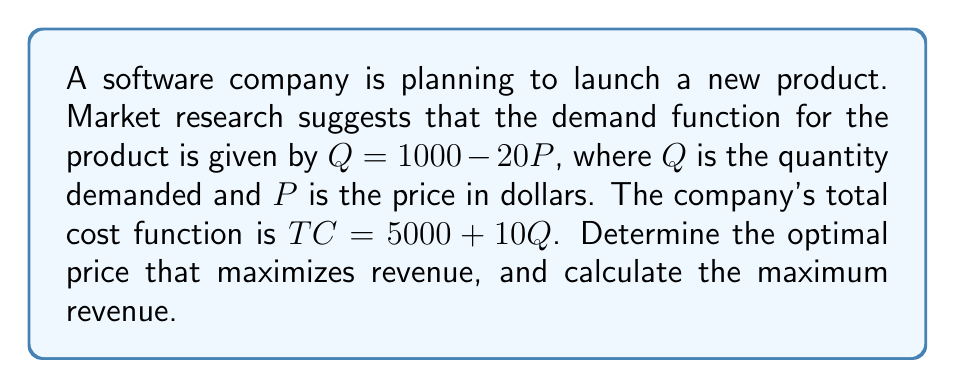Could you help me with this problem? To solve this problem, we'll follow these steps:

1. Define the revenue function
2. Find the first derivative of the revenue function
3. Set the derivative to zero and solve for P
4. Verify that this critical point maximizes revenue
5. Calculate the maximum revenue

Step 1: Define the revenue function
Revenue (R) is price times quantity: $R = P \cdot Q$
Substituting the demand function: $R = P \cdot (1000 - 20P) = 1000P - 20P^2$

Step 2: Find the first derivative of the revenue function
$$\frac{dR}{dP} = 1000 - 40P$$

Step 3: Set the derivative to zero and solve for P
$$1000 - 40P = 0$$
$$40P = 1000$$
$$P = 25$$

Step 4: Verify that this critical point maximizes revenue
To confirm this is a maximum, we can check the second derivative:
$$\frac{d^2R}{dP^2} = -40$$
Since the second derivative is negative, $P = 25$ is indeed a maximum.

Step 5: Calculate the maximum revenue
At $P = 25$, the quantity demanded is:
$$Q = 1000 - 20(25) = 500$$

Therefore, the maximum revenue is:
$$R = 25 \cdot 500 = 12,500$$
Answer: The optimal price that maximizes revenue is $25 per unit, and the maximum revenue is $12,500. 